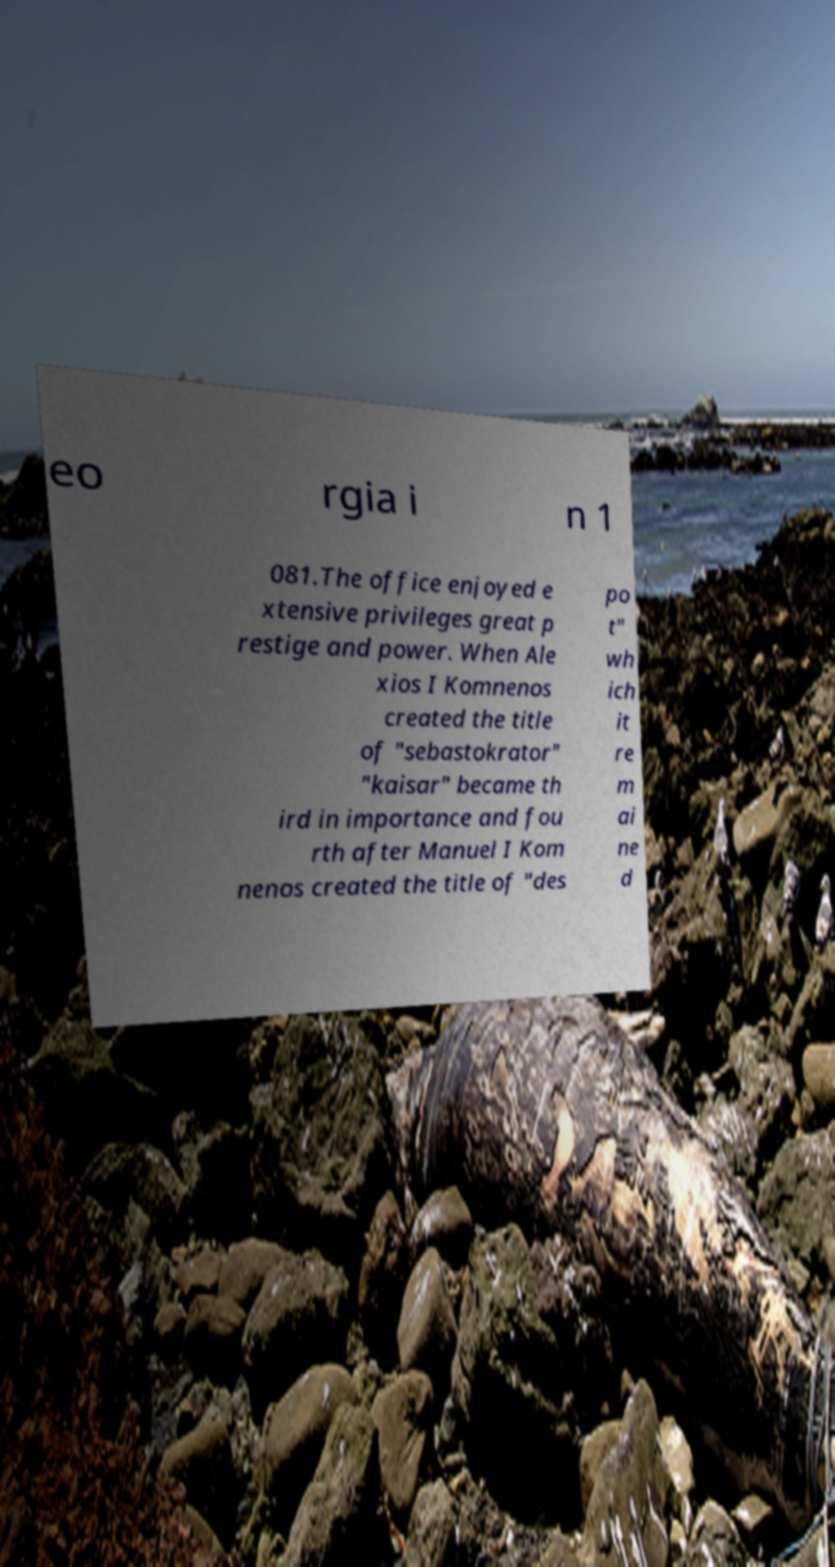I need the written content from this picture converted into text. Can you do that? eo rgia i n 1 081.The office enjoyed e xtensive privileges great p restige and power. When Ale xios I Komnenos created the title of "sebastokrator" "kaisar" became th ird in importance and fou rth after Manuel I Kom nenos created the title of "des po t" wh ich it re m ai ne d 